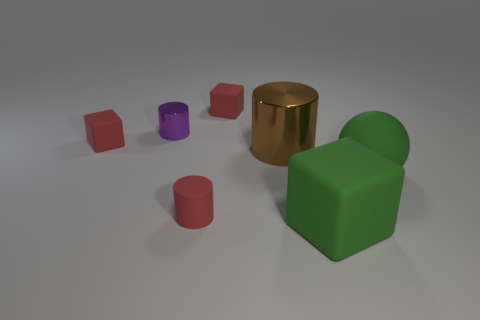Are there any large rubber balls that have the same color as the large block?
Ensure brevity in your answer.  Yes. Is the size of the purple shiny cylinder the same as the brown object?
Offer a terse response. No. What is the material of the green thing left of the large ball?
Offer a very short reply. Rubber. How many other things are the same shape as the small purple object?
Keep it short and to the point. 2. There is a brown thing; are there any red things in front of it?
Offer a terse response. Yes. How many things are either large rubber spheres or matte objects?
Provide a short and direct response. 5. What number of other objects are the same size as the purple thing?
Ensure brevity in your answer.  3. What number of small matte things are in front of the tiny purple cylinder and right of the tiny metal cylinder?
Provide a short and direct response. 1. Does the cylinder that is in front of the big brown cylinder have the same size as the green rubber thing in front of the red cylinder?
Keep it short and to the point. No. There is a matte block that is right of the big shiny object; what size is it?
Your answer should be compact. Large. 